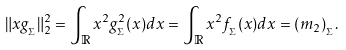<formula> <loc_0><loc_0><loc_500><loc_500>\| x g _ { _ { \Sigma } } \| _ { 2 } ^ { 2 } = \int _ { \mathbb { R } } x ^ { 2 } g ^ { 2 } _ { _ { \Sigma } } ( x ) d x = \int _ { \mathbb { R } } x ^ { 2 } f _ { _ { \Sigma } } ( x ) d x = ( m _ { 2 } ) _ { _ { \Sigma } } .</formula> 